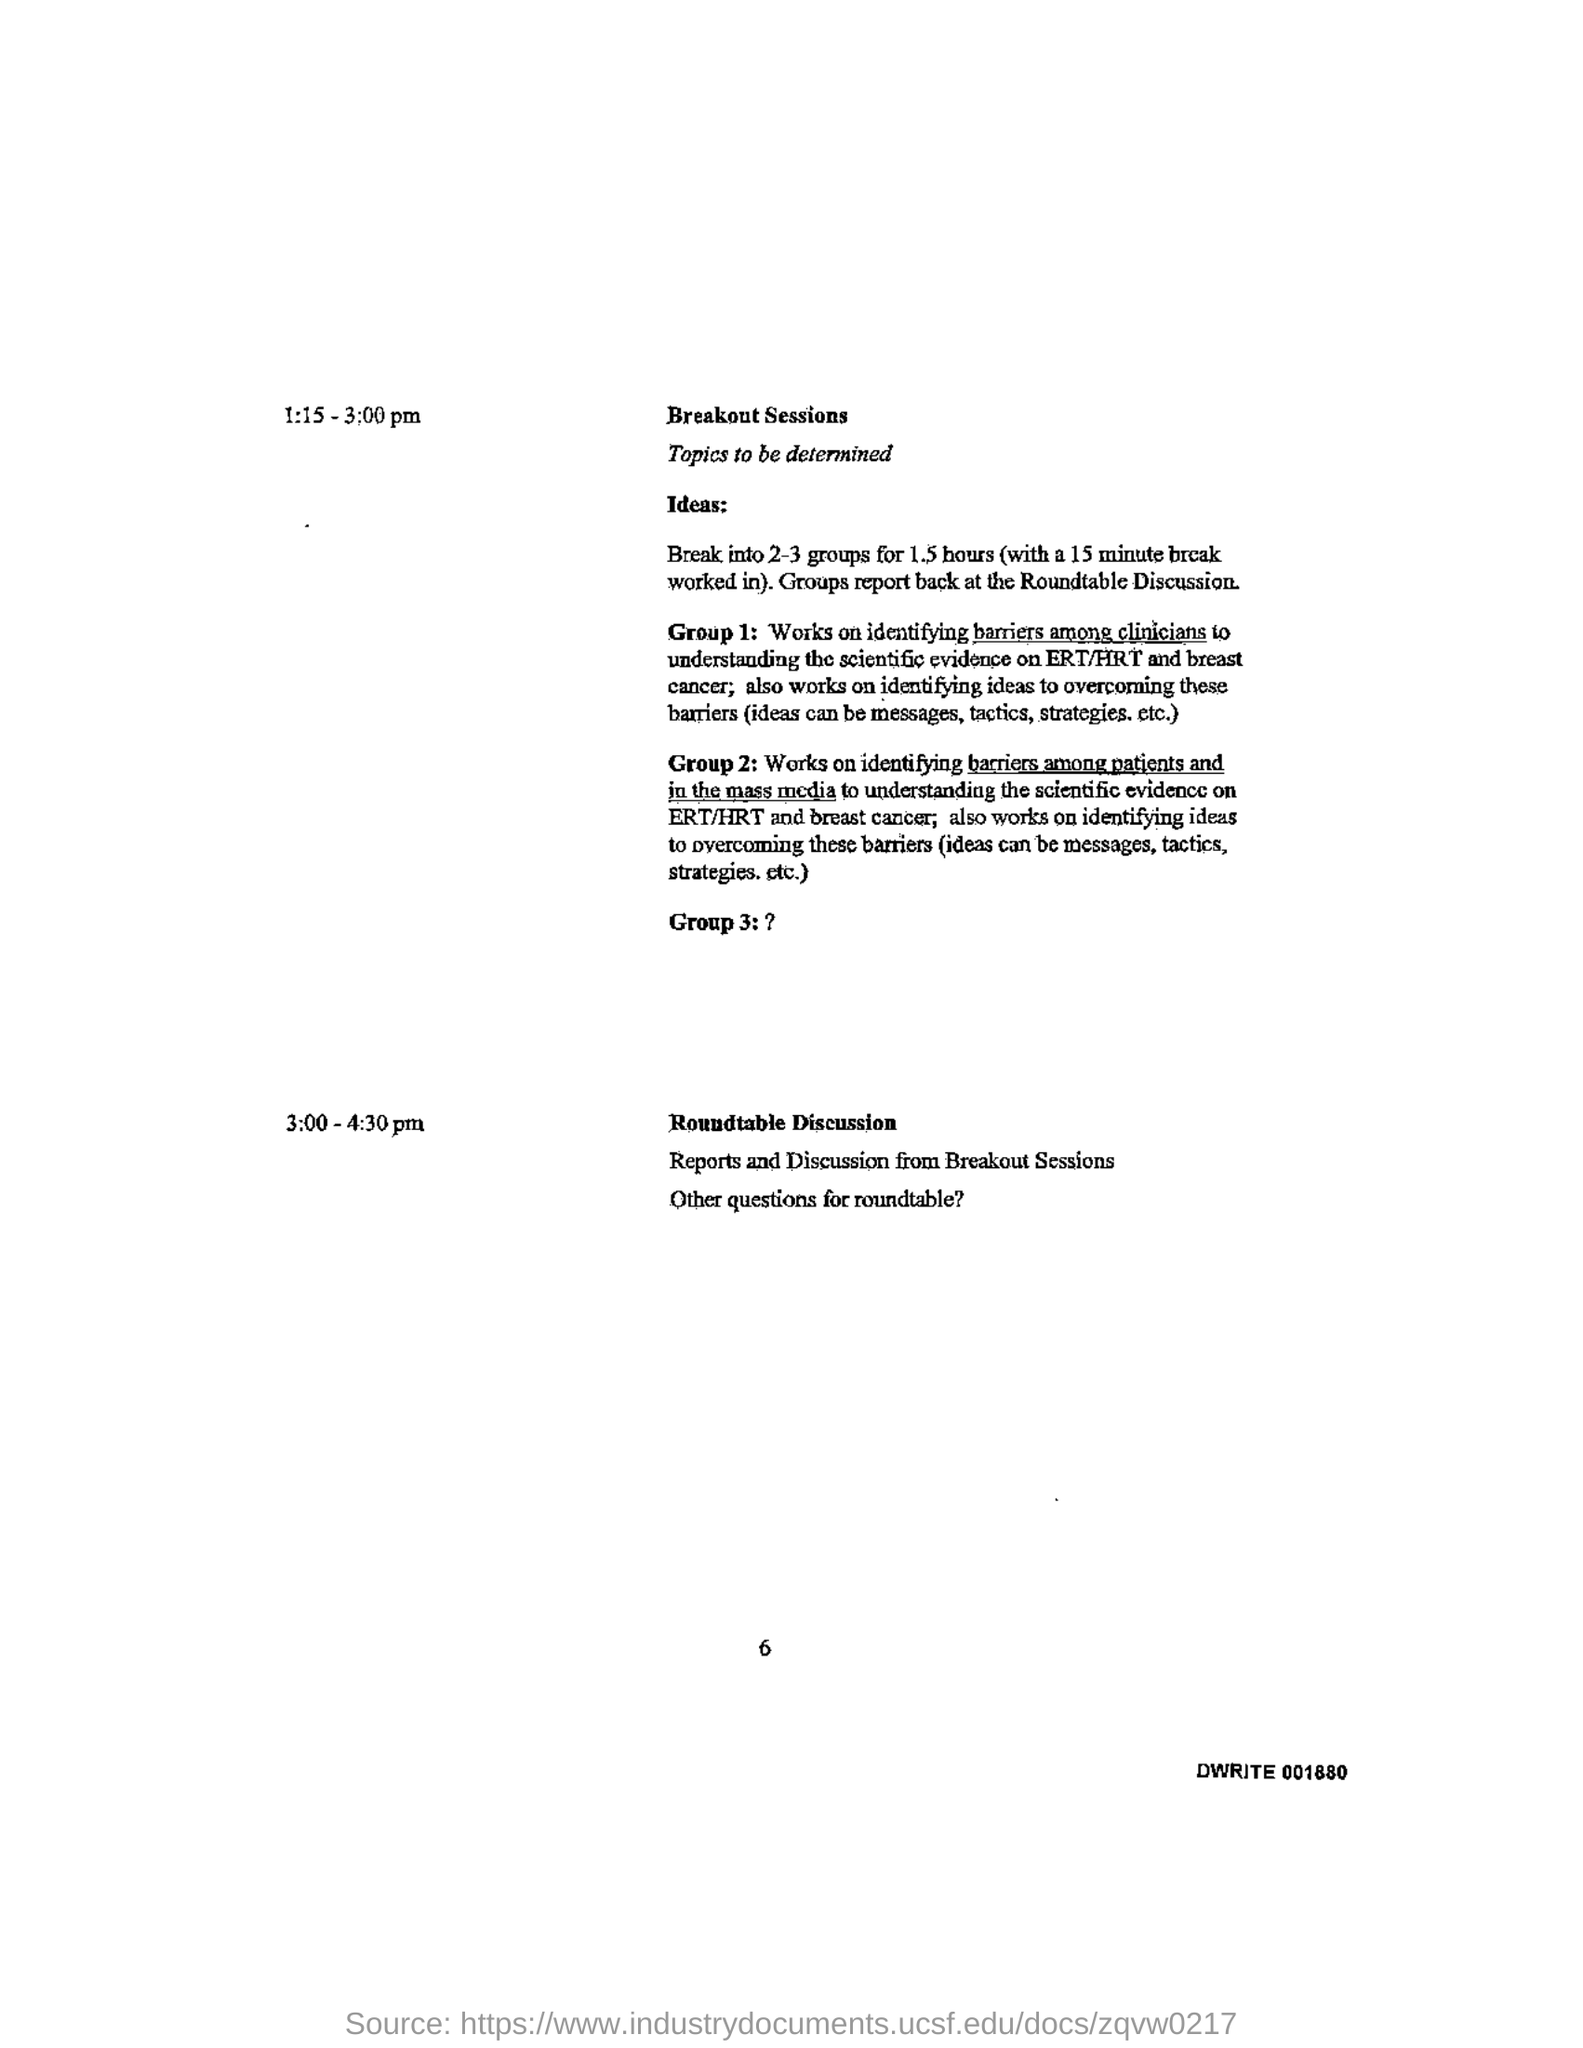List a handful of essential elements in this visual. The roundtable discussion is scheduled to take place from 3:00 pm to 4:30 pm. The breakout sessions are scheduled to take place from 1:15 pm to 3:00 pm. 